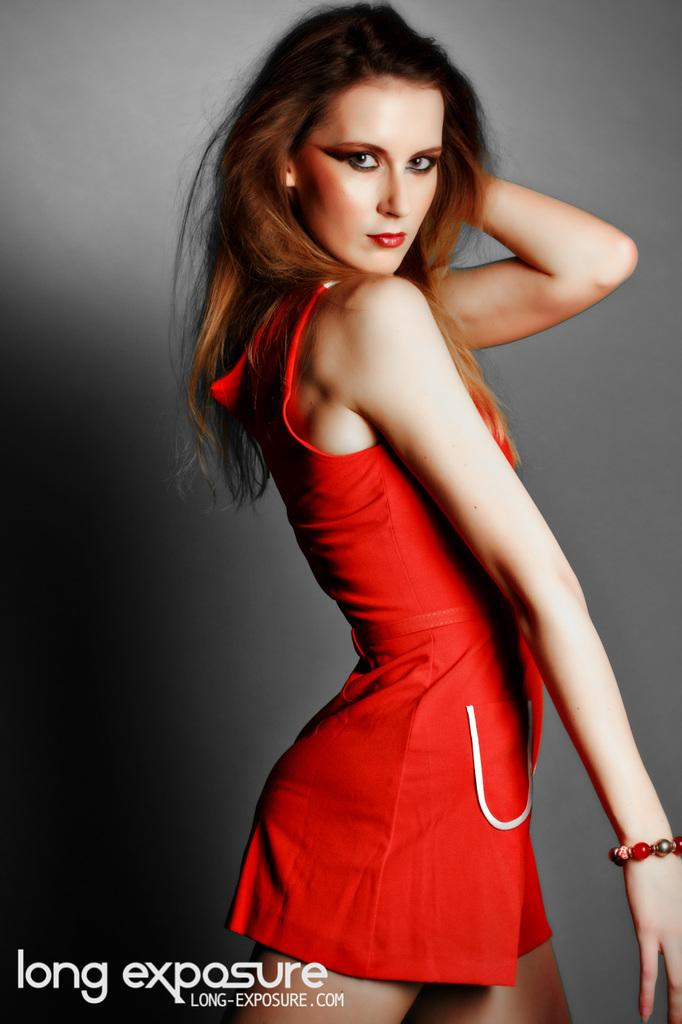<image>
Offer a succinct explanation of the picture presented. A woman in a red dress is posing above a caption that says long exposure. 